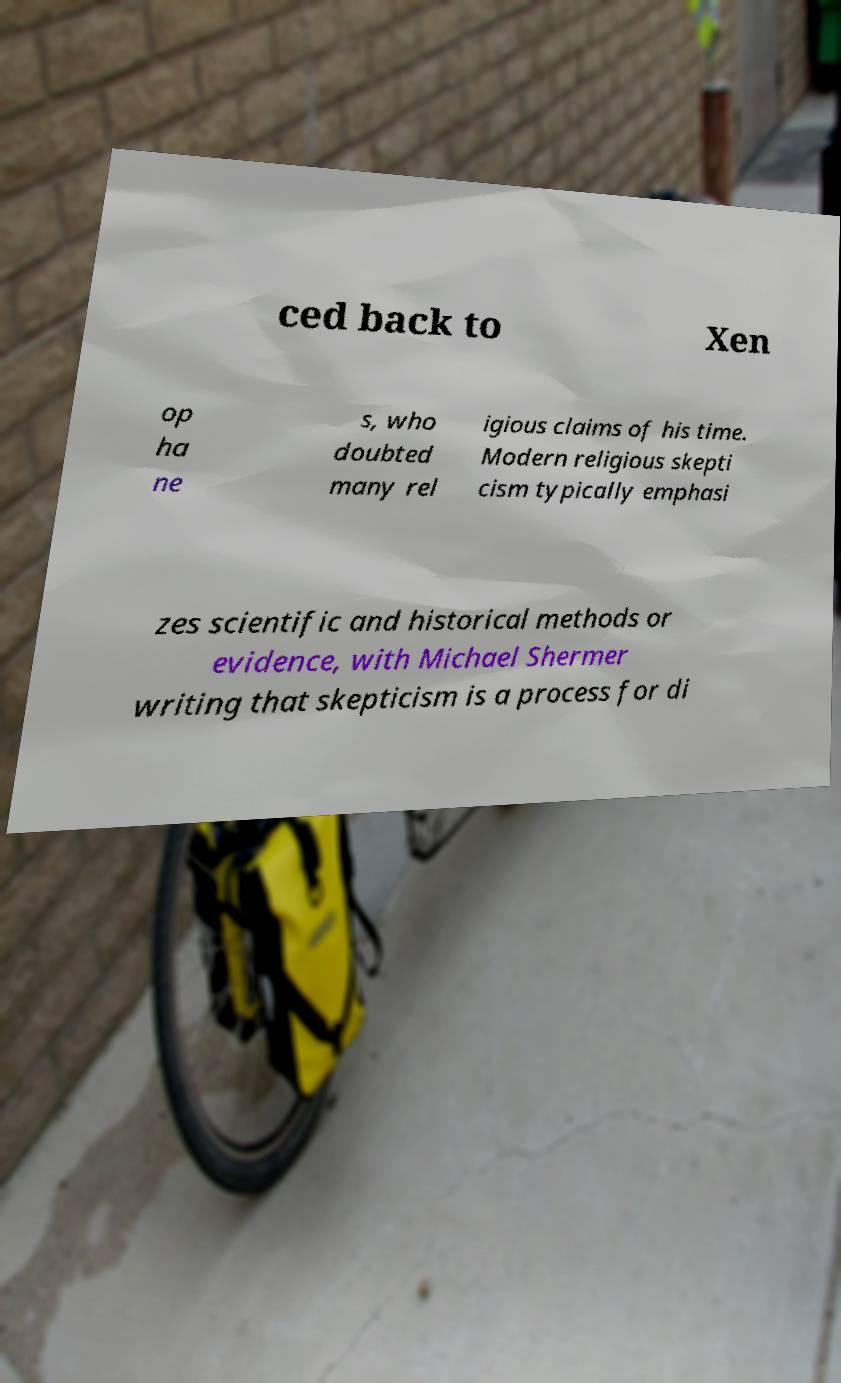There's text embedded in this image that I need extracted. Can you transcribe it verbatim? ced back to Xen op ha ne s, who doubted many rel igious claims of his time. Modern religious skepti cism typically emphasi zes scientific and historical methods or evidence, with Michael Shermer writing that skepticism is a process for di 